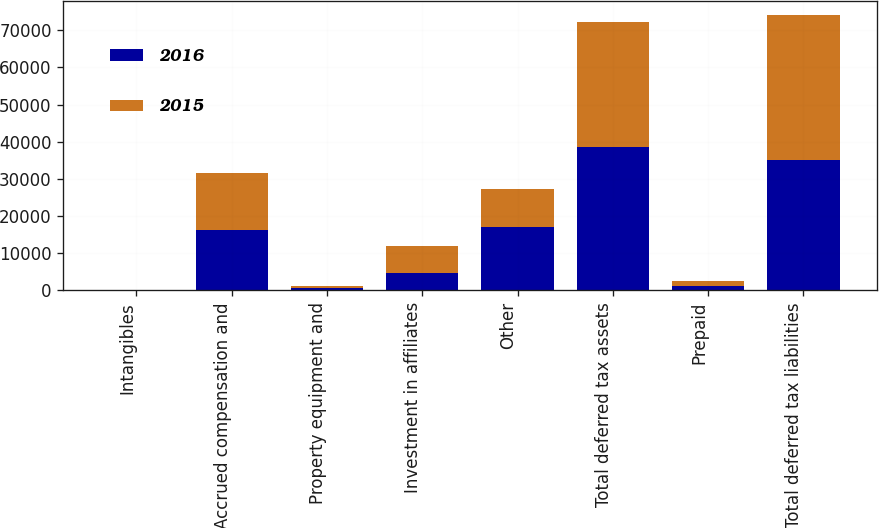Convert chart to OTSL. <chart><loc_0><loc_0><loc_500><loc_500><stacked_bar_chart><ecel><fcel>Intangibles<fcel>Accrued compensation and<fcel>Property equipment and<fcel>Investment in affiliates<fcel>Other<fcel>Total deferred tax assets<fcel>Prepaid<fcel>Total deferred tax liabilities<nl><fcel>2016<fcel>32<fcel>16317<fcel>619<fcel>4668<fcel>17052<fcel>38688<fcel>1145<fcel>35194<nl><fcel>2015<fcel>38<fcel>15406<fcel>645<fcel>7264<fcel>10211<fcel>33564<fcel>1303<fcel>38873<nl></chart> 